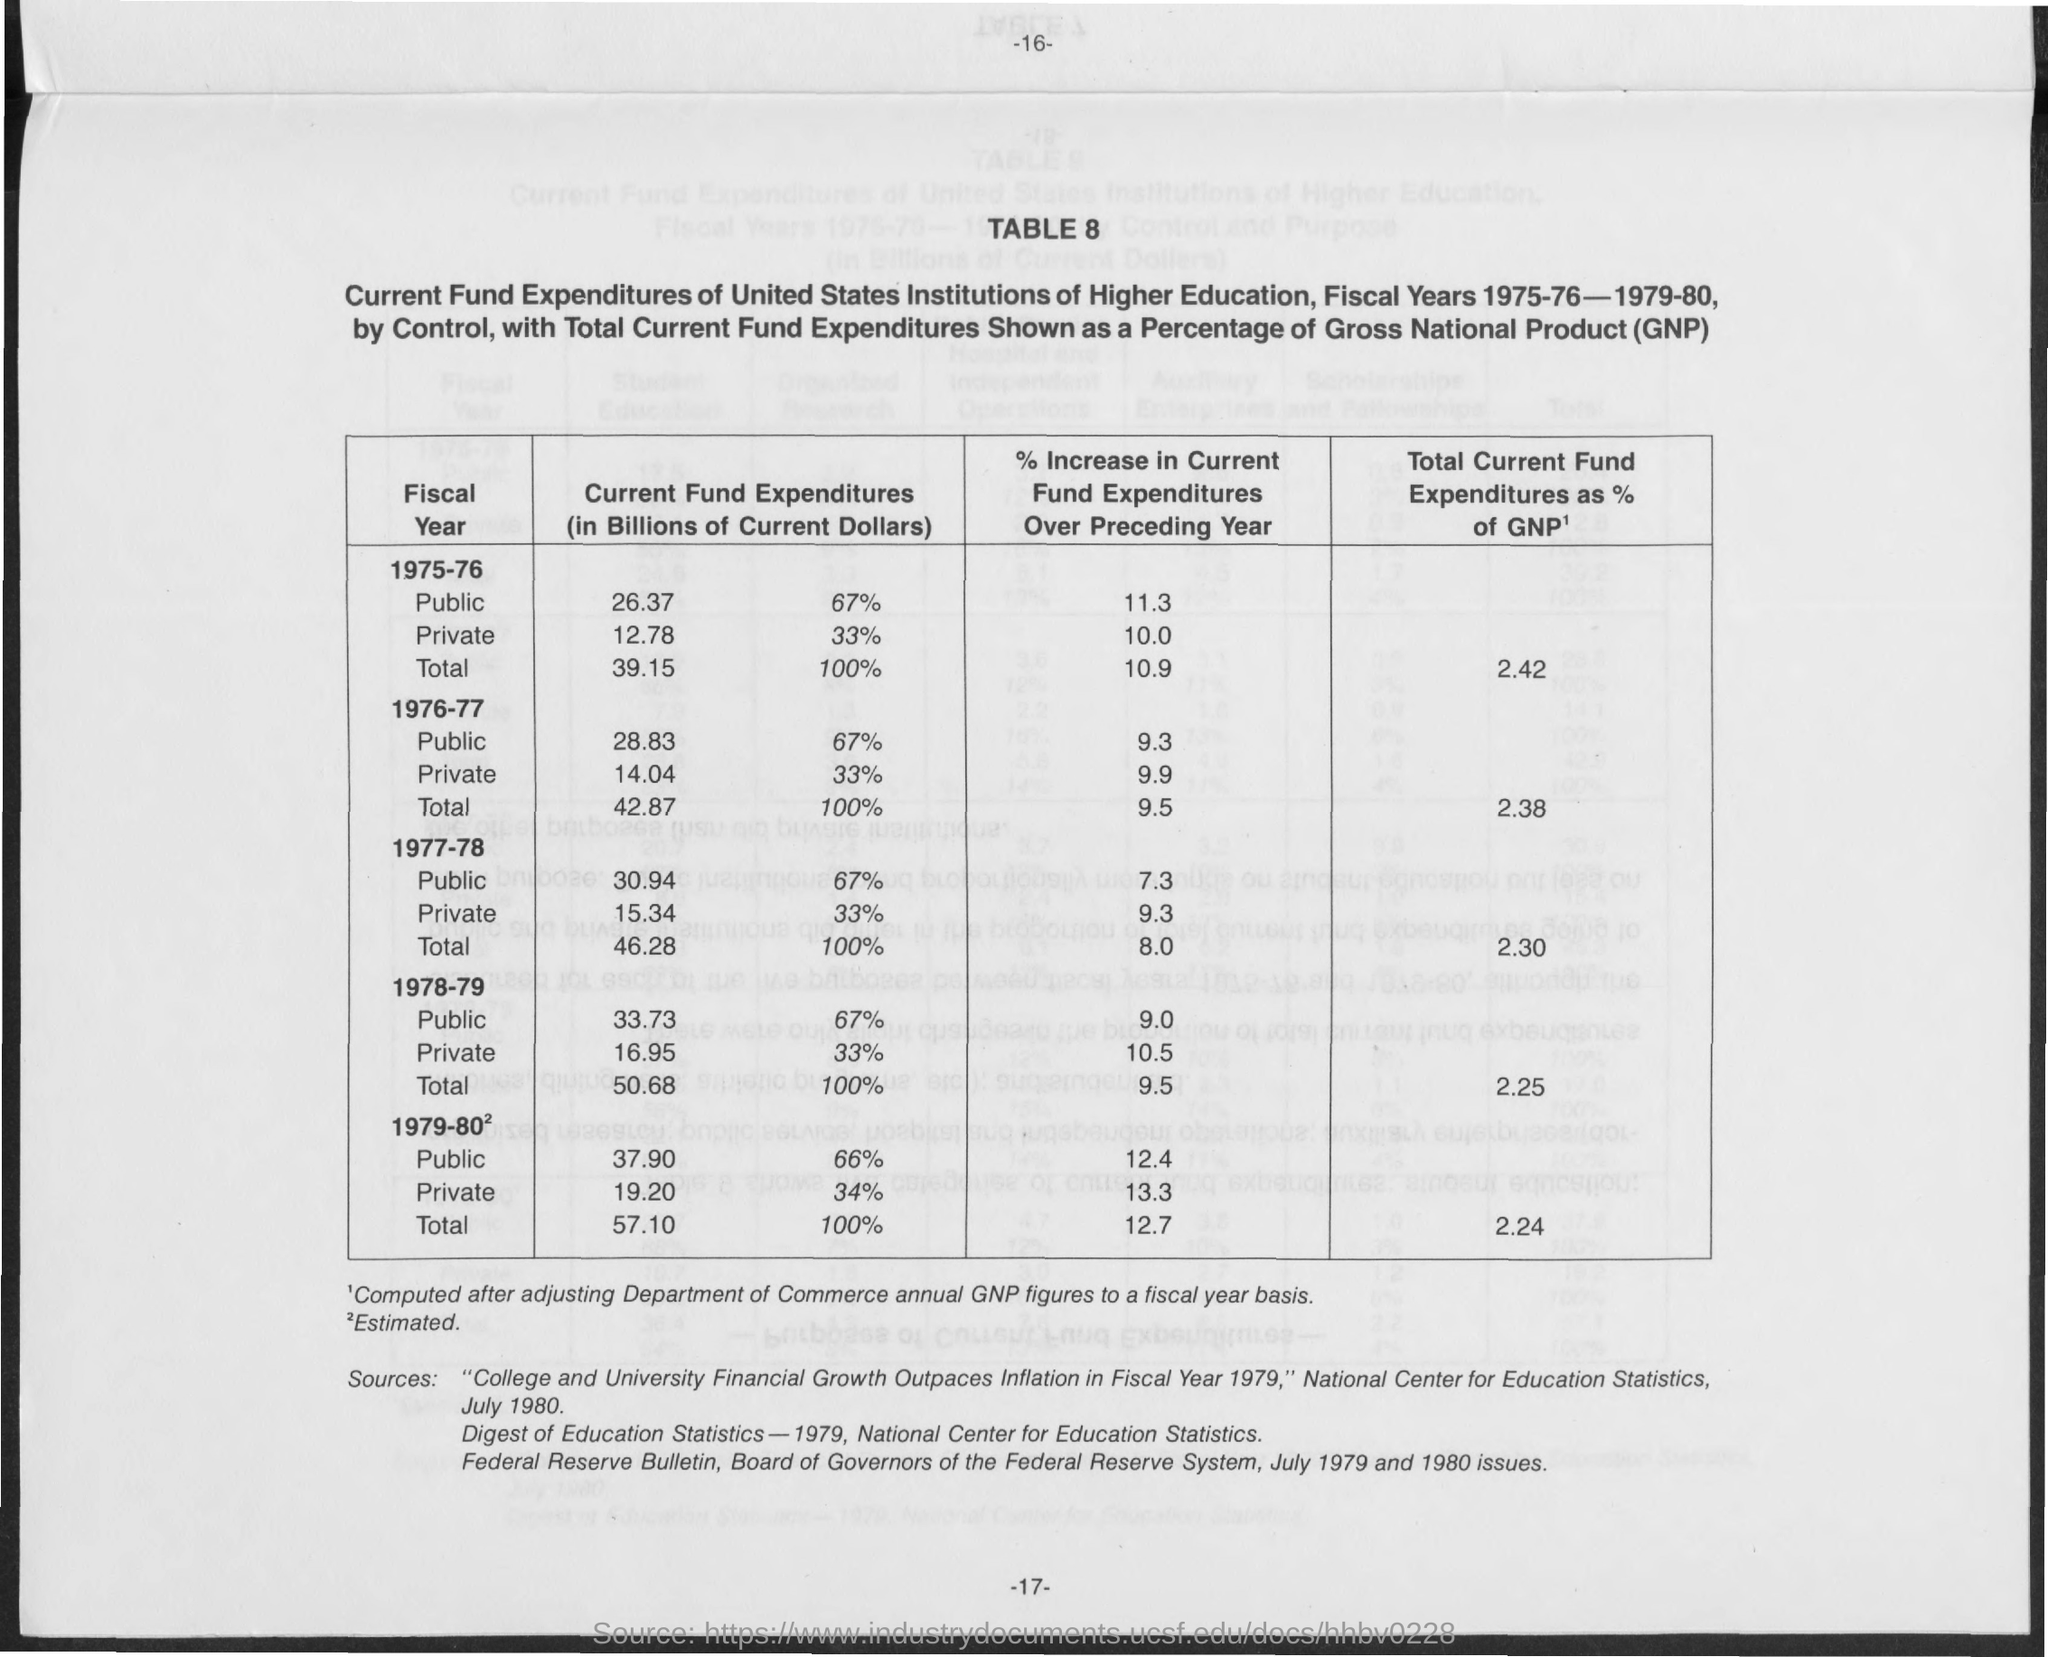What is the Total Current Fund Expenditures as % of GNP for 1975-76?
Your answer should be very brief. 2.42. What is the Total Current Fund Expenditures as % of GNP for 1976-77?
Provide a short and direct response. 2.38. What is the Total Current Fund Expenditures as % of GNP for 1977-78?
Your response must be concise. 2.30. What is the Total Current Fund Expenditures as % of GNP for 1978-79?
Make the answer very short. 2.25. What is the Total Current Fund Expenditures as % of GNP for 1979-80?
Your response must be concise. 2.24. What does GNP stand for?
Your response must be concise. Gross National Product. 